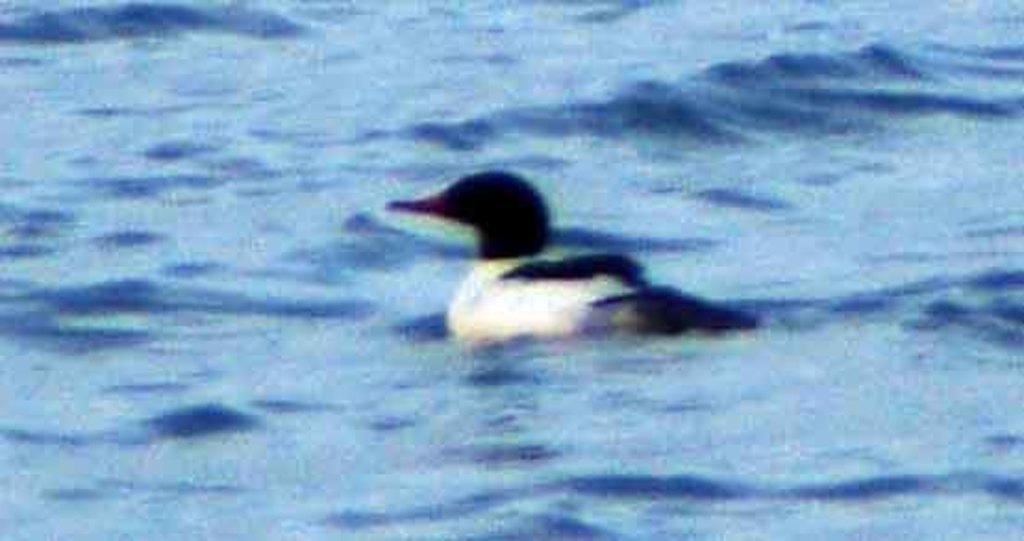How would you summarize this image in a sentence or two? Here in this picture we can see a black and white colored duct present in the water over there. 